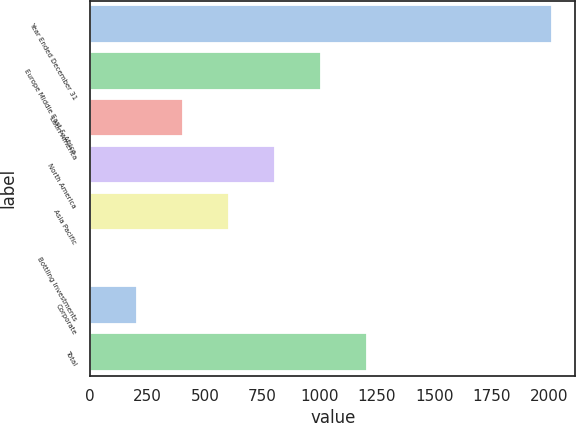Convert chart. <chart><loc_0><loc_0><loc_500><loc_500><bar_chart><fcel>Year Ended December 31<fcel>Europe Middle East & Africa<fcel>Latin America<fcel>North America<fcel>Asia Pacific<fcel>Bottling Investments<fcel>Corporate<fcel>Total<nl><fcel>2015<fcel>1008.2<fcel>404.12<fcel>806.84<fcel>605.48<fcel>1.4<fcel>202.76<fcel>1209.56<nl></chart> 